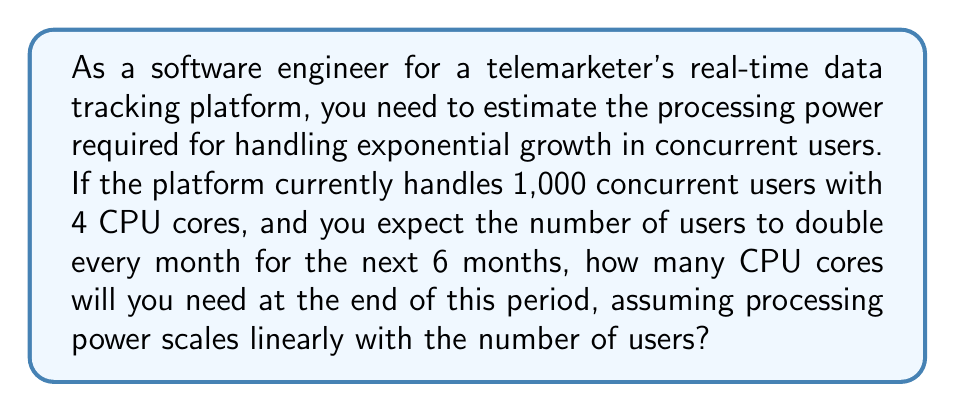Teach me how to tackle this problem. Let's approach this step-by-step:

1) First, we need to calculate the number of users after 6 months of doubling:
   Initial users: $1,000$
   After 6 months: $1,000 * 2^6 = 1,000 * 64 = 64,000$ users

2) Now, we need to set up a proportion to determine the number of CPU cores needed:
   $$\frac{1,000 \text{ users}}{4 \text{ cores}} = \frac{64,000 \text{ users}}{x \text{ cores}}$$

3) Cross multiply:
   $$1,000x = 4 * 64,000$$

4) Solve for $x$:
   $$x = \frac{4 * 64,000}{1,000} = 256$$

Therefore, you will need 256 CPU cores to handle the increased load after 6 months of exponential growth.

Note: This assumes a linear relationship between users and processing power, which may not always be the case in real-world scenarios. Factors like optimization, caching, and the nature of operations could affect the actual scaling.
Answer: 256 CPU cores 